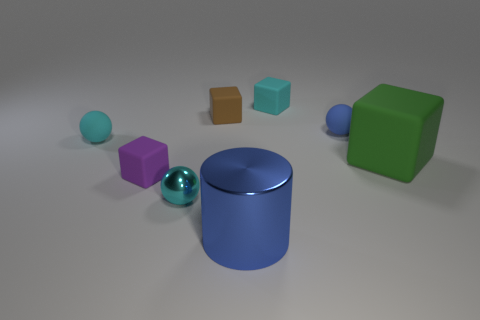There is a cyan thing in front of the tiny rubber ball that is to the left of the blue shiny cylinder; how many tiny cyan matte objects are right of it?
Your answer should be very brief. 1. Are there any other large shiny cylinders that have the same color as the metal cylinder?
Make the answer very short. No. What color is the metal ball that is the same size as the purple matte thing?
Ensure brevity in your answer.  Cyan. What shape is the metal object in front of the metallic thing to the left of the blue object on the left side of the small blue matte sphere?
Make the answer very short. Cylinder. There is a big shiny cylinder in front of the blue matte object; how many tiny spheres are to the right of it?
Your response must be concise. 1. Does the blue thing to the left of the cyan cube have the same shape as the blue thing behind the large blue cylinder?
Give a very brief answer. No. There is a large cube; how many small shiny things are behind it?
Your answer should be compact. 0. Is the material of the big object that is to the right of the cylinder the same as the big blue object?
Provide a short and direct response. No. There is a big matte object that is the same shape as the small brown matte object; what color is it?
Your answer should be very brief. Green. The cyan shiny object is what shape?
Keep it short and to the point. Sphere. 